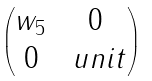<formula> <loc_0><loc_0><loc_500><loc_500>\begin{pmatrix} w _ { 5 } & 0 \\ 0 & \ u n i t \end{pmatrix}</formula> 